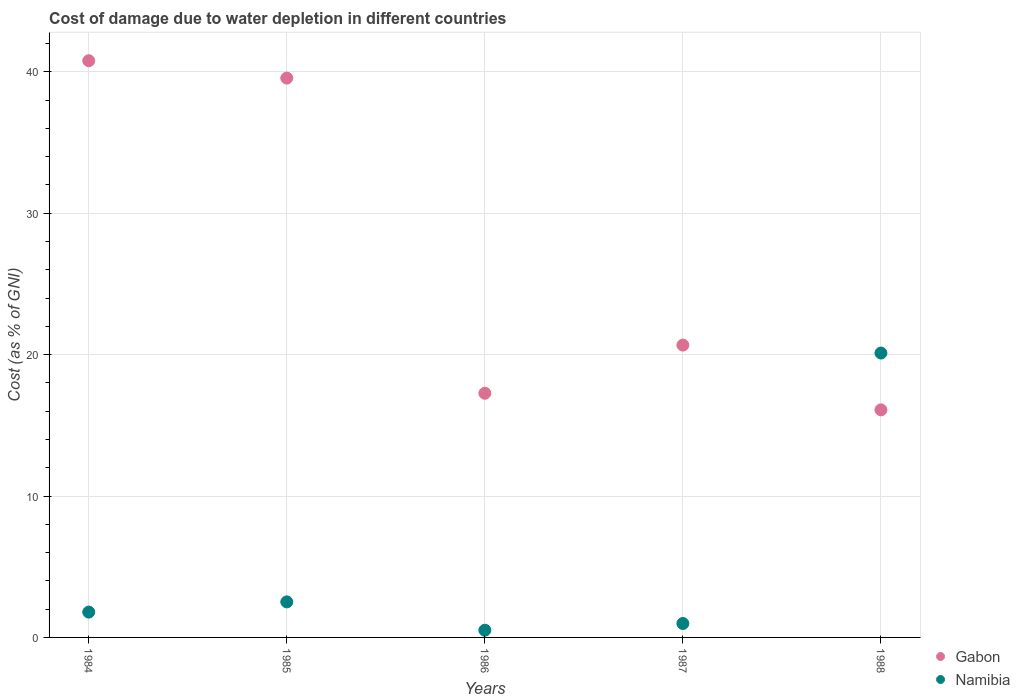Is the number of dotlines equal to the number of legend labels?
Offer a terse response. Yes. What is the cost of damage caused due to water depletion in Namibia in 1988?
Provide a short and direct response. 20.11. Across all years, what is the maximum cost of damage caused due to water depletion in Namibia?
Give a very brief answer. 20.11. Across all years, what is the minimum cost of damage caused due to water depletion in Gabon?
Your answer should be compact. 16.09. In which year was the cost of damage caused due to water depletion in Namibia minimum?
Your response must be concise. 1986. What is the total cost of damage caused due to water depletion in Gabon in the graph?
Offer a very short reply. 134.38. What is the difference between the cost of damage caused due to water depletion in Gabon in 1986 and that in 1988?
Your answer should be very brief. 1.17. What is the difference between the cost of damage caused due to water depletion in Gabon in 1984 and the cost of damage caused due to water depletion in Namibia in 1987?
Your answer should be compact. 39.8. What is the average cost of damage caused due to water depletion in Gabon per year?
Make the answer very short. 26.88. In the year 1988, what is the difference between the cost of damage caused due to water depletion in Gabon and cost of damage caused due to water depletion in Namibia?
Your answer should be compact. -4.02. What is the ratio of the cost of damage caused due to water depletion in Namibia in 1984 to that in 1988?
Keep it short and to the point. 0.09. Is the difference between the cost of damage caused due to water depletion in Gabon in 1985 and 1987 greater than the difference between the cost of damage caused due to water depletion in Namibia in 1985 and 1987?
Your answer should be very brief. Yes. What is the difference between the highest and the second highest cost of damage caused due to water depletion in Namibia?
Ensure brevity in your answer.  17.6. What is the difference between the highest and the lowest cost of damage caused due to water depletion in Gabon?
Keep it short and to the point. 24.69. Is the sum of the cost of damage caused due to water depletion in Namibia in 1984 and 1985 greater than the maximum cost of damage caused due to water depletion in Gabon across all years?
Provide a short and direct response. No. Does the cost of damage caused due to water depletion in Namibia monotonically increase over the years?
Give a very brief answer. No. Is the cost of damage caused due to water depletion in Namibia strictly greater than the cost of damage caused due to water depletion in Gabon over the years?
Provide a short and direct response. No. Is the cost of damage caused due to water depletion in Gabon strictly less than the cost of damage caused due to water depletion in Namibia over the years?
Your response must be concise. No. How many years are there in the graph?
Provide a short and direct response. 5. What is the difference between two consecutive major ticks on the Y-axis?
Give a very brief answer. 10. Does the graph contain any zero values?
Your answer should be very brief. No. Does the graph contain grids?
Provide a short and direct response. Yes. Where does the legend appear in the graph?
Your response must be concise. Bottom right. How many legend labels are there?
Provide a succinct answer. 2. What is the title of the graph?
Keep it short and to the point. Cost of damage due to water depletion in different countries. Does "Lao PDR" appear as one of the legend labels in the graph?
Offer a terse response. No. What is the label or title of the X-axis?
Provide a succinct answer. Years. What is the label or title of the Y-axis?
Offer a terse response. Cost (as % of GNI). What is the Cost (as % of GNI) of Gabon in 1984?
Provide a succinct answer. 40.79. What is the Cost (as % of GNI) in Namibia in 1984?
Provide a succinct answer. 1.79. What is the Cost (as % of GNI) of Gabon in 1985?
Provide a short and direct response. 39.56. What is the Cost (as % of GNI) in Namibia in 1985?
Offer a terse response. 2.51. What is the Cost (as % of GNI) in Gabon in 1986?
Provide a succinct answer. 17.27. What is the Cost (as % of GNI) of Namibia in 1986?
Offer a very short reply. 0.51. What is the Cost (as % of GNI) in Gabon in 1987?
Your answer should be compact. 20.68. What is the Cost (as % of GNI) of Namibia in 1987?
Provide a succinct answer. 0.99. What is the Cost (as % of GNI) of Gabon in 1988?
Your answer should be compact. 16.09. What is the Cost (as % of GNI) in Namibia in 1988?
Give a very brief answer. 20.11. Across all years, what is the maximum Cost (as % of GNI) in Gabon?
Make the answer very short. 40.79. Across all years, what is the maximum Cost (as % of GNI) of Namibia?
Keep it short and to the point. 20.11. Across all years, what is the minimum Cost (as % of GNI) in Gabon?
Make the answer very short. 16.09. Across all years, what is the minimum Cost (as % of GNI) in Namibia?
Ensure brevity in your answer.  0.51. What is the total Cost (as % of GNI) of Gabon in the graph?
Make the answer very short. 134.38. What is the total Cost (as % of GNI) in Namibia in the graph?
Offer a terse response. 25.91. What is the difference between the Cost (as % of GNI) of Gabon in 1984 and that in 1985?
Provide a succinct answer. 1.23. What is the difference between the Cost (as % of GNI) of Namibia in 1984 and that in 1985?
Offer a terse response. -0.72. What is the difference between the Cost (as % of GNI) of Gabon in 1984 and that in 1986?
Give a very brief answer. 23.52. What is the difference between the Cost (as % of GNI) of Namibia in 1984 and that in 1986?
Offer a terse response. 1.28. What is the difference between the Cost (as % of GNI) in Gabon in 1984 and that in 1987?
Ensure brevity in your answer.  20.11. What is the difference between the Cost (as % of GNI) of Namibia in 1984 and that in 1987?
Your response must be concise. 0.81. What is the difference between the Cost (as % of GNI) of Gabon in 1984 and that in 1988?
Keep it short and to the point. 24.69. What is the difference between the Cost (as % of GNI) in Namibia in 1984 and that in 1988?
Your response must be concise. -18.32. What is the difference between the Cost (as % of GNI) in Gabon in 1985 and that in 1986?
Provide a succinct answer. 22.29. What is the difference between the Cost (as % of GNI) in Namibia in 1985 and that in 1986?
Provide a succinct answer. 2. What is the difference between the Cost (as % of GNI) in Gabon in 1985 and that in 1987?
Your answer should be compact. 18.88. What is the difference between the Cost (as % of GNI) of Namibia in 1985 and that in 1987?
Your answer should be very brief. 1.53. What is the difference between the Cost (as % of GNI) of Gabon in 1985 and that in 1988?
Ensure brevity in your answer.  23.46. What is the difference between the Cost (as % of GNI) in Namibia in 1985 and that in 1988?
Keep it short and to the point. -17.6. What is the difference between the Cost (as % of GNI) of Gabon in 1986 and that in 1987?
Offer a very short reply. -3.41. What is the difference between the Cost (as % of GNI) in Namibia in 1986 and that in 1987?
Make the answer very short. -0.48. What is the difference between the Cost (as % of GNI) of Gabon in 1986 and that in 1988?
Keep it short and to the point. 1.17. What is the difference between the Cost (as % of GNI) of Namibia in 1986 and that in 1988?
Give a very brief answer. -19.6. What is the difference between the Cost (as % of GNI) in Gabon in 1987 and that in 1988?
Give a very brief answer. 4.58. What is the difference between the Cost (as % of GNI) of Namibia in 1987 and that in 1988?
Offer a very short reply. -19.13. What is the difference between the Cost (as % of GNI) in Gabon in 1984 and the Cost (as % of GNI) in Namibia in 1985?
Your response must be concise. 38.27. What is the difference between the Cost (as % of GNI) in Gabon in 1984 and the Cost (as % of GNI) in Namibia in 1986?
Provide a short and direct response. 40.28. What is the difference between the Cost (as % of GNI) of Gabon in 1984 and the Cost (as % of GNI) of Namibia in 1987?
Offer a terse response. 39.8. What is the difference between the Cost (as % of GNI) in Gabon in 1984 and the Cost (as % of GNI) in Namibia in 1988?
Keep it short and to the point. 20.67. What is the difference between the Cost (as % of GNI) in Gabon in 1985 and the Cost (as % of GNI) in Namibia in 1986?
Provide a short and direct response. 39.05. What is the difference between the Cost (as % of GNI) in Gabon in 1985 and the Cost (as % of GNI) in Namibia in 1987?
Offer a terse response. 38.57. What is the difference between the Cost (as % of GNI) of Gabon in 1985 and the Cost (as % of GNI) of Namibia in 1988?
Keep it short and to the point. 19.44. What is the difference between the Cost (as % of GNI) in Gabon in 1986 and the Cost (as % of GNI) in Namibia in 1987?
Give a very brief answer. 16.28. What is the difference between the Cost (as % of GNI) in Gabon in 1986 and the Cost (as % of GNI) in Namibia in 1988?
Make the answer very short. -2.84. What is the difference between the Cost (as % of GNI) in Gabon in 1987 and the Cost (as % of GNI) in Namibia in 1988?
Your response must be concise. 0.56. What is the average Cost (as % of GNI) of Gabon per year?
Give a very brief answer. 26.88. What is the average Cost (as % of GNI) of Namibia per year?
Make the answer very short. 5.18. In the year 1984, what is the difference between the Cost (as % of GNI) of Gabon and Cost (as % of GNI) of Namibia?
Ensure brevity in your answer.  38.99. In the year 1985, what is the difference between the Cost (as % of GNI) of Gabon and Cost (as % of GNI) of Namibia?
Offer a very short reply. 37.05. In the year 1986, what is the difference between the Cost (as % of GNI) of Gabon and Cost (as % of GNI) of Namibia?
Offer a terse response. 16.76. In the year 1987, what is the difference between the Cost (as % of GNI) of Gabon and Cost (as % of GNI) of Namibia?
Offer a very short reply. 19.69. In the year 1988, what is the difference between the Cost (as % of GNI) of Gabon and Cost (as % of GNI) of Namibia?
Make the answer very short. -4.02. What is the ratio of the Cost (as % of GNI) of Gabon in 1984 to that in 1985?
Provide a succinct answer. 1.03. What is the ratio of the Cost (as % of GNI) in Namibia in 1984 to that in 1985?
Provide a succinct answer. 0.71. What is the ratio of the Cost (as % of GNI) of Gabon in 1984 to that in 1986?
Provide a short and direct response. 2.36. What is the ratio of the Cost (as % of GNI) in Namibia in 1984 to that in 1986?
Keep it short and to the point. 3.52. What is the ratio of the Cost (as % of GNI) in Gabon in 1984 to that in 1987?
Make the answer very short. 1.97. What is the ratio of the Cost (as % of GNI) of Namibia in 1984 to that in 1987?
Your answer should be very brief. 1.82. What is the ratio of the Cost (as % of GNI) in Gabon in 1984 to that in 1988?
Your answer should be very brief. 2.53. What is the ratio of the Cost (as % of GNI) of Namibia in 1984 to that in 1988?
Ensure brevity in your answer.  0.09. What is the ratio of the Cost (as % of GNI) of Gabon in 1985 to that in 1986?
Your answer should be compact. 2.29. What is the ratio of the Cost (as % of GNI) in Namibia in 1985 to that in 1986?
Offer a terse response. 4.94. What is the ratio of the Cost (as % of GNI) of Gabon in 1985 to that in 1987?
Your answer should be very brief. 1.91. What is the ratio of the Cost (as % of GNI) of Namibia in 1985 to that in 1987?
Offer a terse response. 2.55. What is the ratio of the Cost (as % of GNI) in Gabon in 1985 to that in 1988?
Offer a terse response. 2.46. What is the ratio of the Cost (as % of GNI) of Namibia in 1985 to that in 1988?
Provide a succinct answer. 0.12. What is the ratio of the Cost (as % of GNI) in Gabon in 1986 to that in 1987?
Ensure brevity in your answer.  0.84. What is the ratio of the Cost (as % of GNI) of Namibia in 1986 to that in 1987?
Provide a succinct answer. 0.52. What is the ratio of the Cost (as % of GNI) in Gabon in 1986 to that in 1988?
Your answer should be compact. 1.07. What is the ratio of the Cost (as % of GNI) of Namibia in 1986 to that in 1988?
Offer a very short reply. 0.03. What is the ratio of the Cost (as % of GNI) of Gabon in 1987 to that in 1988?
Make the answer very short. 1.28. What is the ratio of the Cost (as % of GNI) of Namibia in 1987 to that in 1988?
Ensure brevity in your answer.  0.05. What is the difference between the highest and the second highest Cost (as % of GNI) in Gabon?
Provide a short and direct response. 1.23. What is the difference between the highest and the second highest Cost (as % of GNI) in Namibia?
Offer a terse response. 17.6. What is the difference between the highest and the lowest Cost (as % of GNI) in Gabon?
Provide a succinct answer. 24.69. What is the difference between the highest and the lowest Cost (as % of GNI) in Namibia?
Your answer should be very brief. 19.6. 